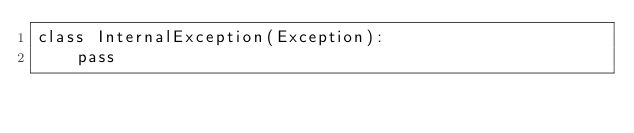Convert code to text. <code><loc_0><loc_0><loc_500><loc_500><_Python_>class InternalException(Exception):
    pass
</code> 